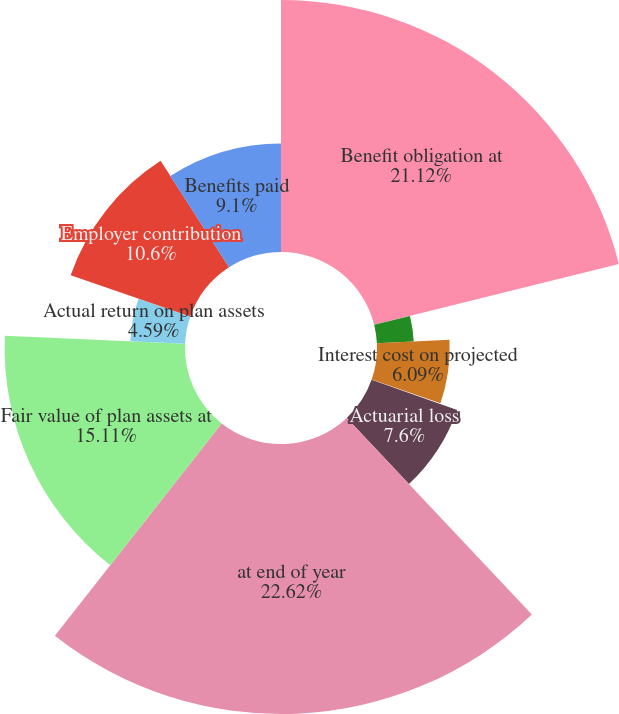Convert chart to OTSL. <chart><loc_0><loc_0><loc_500><loc_500><pie_chart><fcel>Benefit obligation at<fcel>Service cost-benefits earned<fcel>Interest cost on projected<fcel>Plan participants'<fcel>Actuarial loss<fcel>at end of year<fcel>Fair value of plan assets at<fcel>Actual return on plan assets<fcel>Employer contribution<fcel>Benefits paid<nl><fcel>21.12%<fcel>3.09%<fcel>6.09%<fcel>0.08%<fcel>7.6%<fcel>22.62%<fcel>15.11%<fcel>4.59%<fcel>10.6%<fcel>9.1%<nl></chart> 